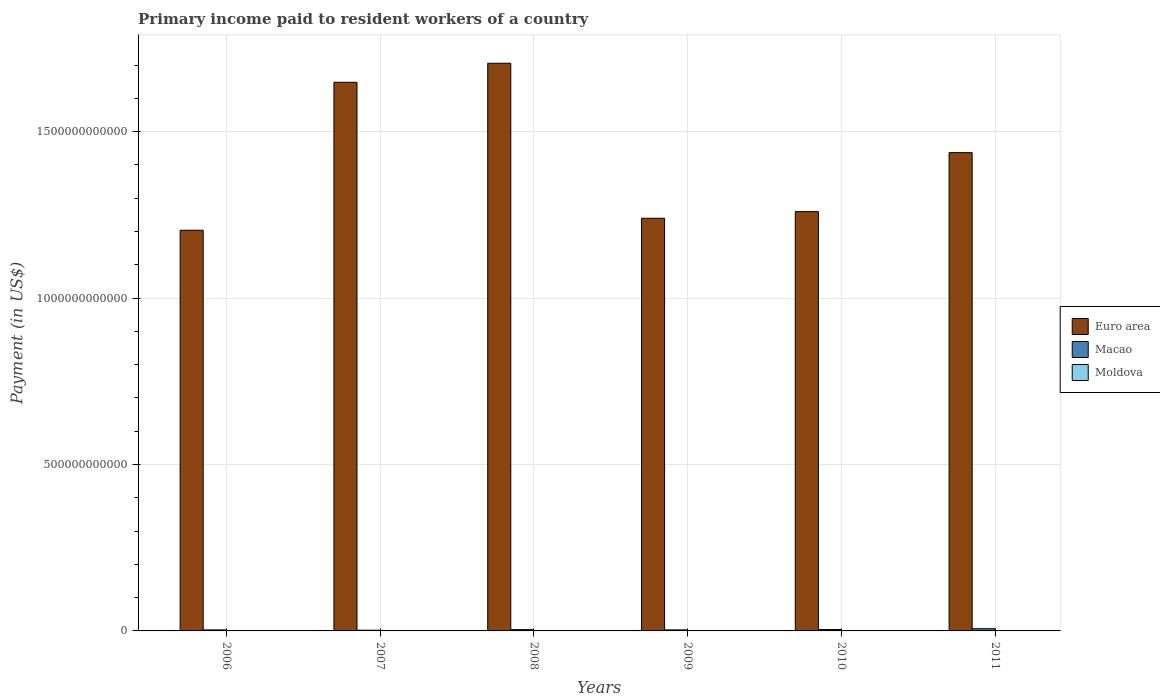How many different coloured bars are there?
Make the answer very short. 3. How many groups of bars are there?
Give a very brief answer. 6. What is the amount paid to workers in Macao in 2006?
Offer a terse response. 3.02e+09. Across all years, what is the maximum amount paid to workers in Euro area?
Give a very brief answer. 1.71e+12. Across all years, what is the minimum amount paid to workers in Macao?
Give a very brief answer. 2.18e+09. In which year was the amount paid to workers in Moldova maximum?
Provide a short and direct response. 2011. In which year was the amount paid to workers in Moldova minimum?
Ensure brevity in your answer.  2006. What is the total amount paid to workers in Macao in the graph?
Provide a short and direct response. 2.30e+1. What is the difference between the amount paid to workers in Euro area in 2007 and that in 2008?
Provide a succinct answer. -5.72e+1. What is the difference between the amount paid to workers in Euro area in 2009 and the amount paid to workers in Moldova in 2006?
Offer a terse response. 1.24e+12. What is the average amount paid to workers in Moldova per year?
Make the answer very short. 2.81e+08. In the year 2010, what is the difference between the amount paid to workers in Euro area and amount paid to workers in Macao?
Make the answer very short. 1.26e+12. What is the ratio of the amount paid to workers in Macao in 2006 to that in 2008?
Keep it short and to the point. 0.78. Is the amount paid to workers in Moldova in 2007 less than that in 2010?
Ensure brevity in your answer.  No. Is the difference between the amount paid to workers in Euro area in 2006 and 2010 greater than the difference between the amount paid to workers in Macao in 2006 and 2010?
Provide a short and direct response. No. What is the difference between the highest and the second highest amount paid to workers in Euro area?
Your answer should be very brief. 5.72e+1. What is the difference between the highest and the lowest amount paid to workers in Macao?
Offer a very short reply. 4.44e+09. Is the sum of the amount paid to workers in Macao in 2009 and 2010 greater than the maximum amount paid to workers in Euro area across all years?
Offer a very short reply. No. What does the 3rd bar from the left in 2007 represents?
Offer a very short reply. Moldova. What does the 3rd bar from the right in 2007 represents?
Ensure brevity in your answer.  Euro area. Is it the case that in every year, the sum of the amount paid to workers in Macao and amount paid to workers in Euro area is greater than the amount paid to workers in Moldova?
Offer a very short reply. Yes. How many bars are there?
Ensure brevity in your answer.  18. How many years are there in the graph?
Provide a short and direct response. 6. What is the difference between two consecutive major ticks on the Y-axis?
Give a very brief answer. 5.00e+11. Are the values on the major ticks of Y-axis written in scientific E-notation?
Your response must be concise. No. Where does the legend appear in the graph?
Your answer should be very brief. Center right. How many legend labels are there?
Make the answer very short. 3. How are the legend labels stacked?
Give a very brief answer. Vertical. What is the title of the graph?
Your answer should be very brief. Primary income paid to resident workers of a country. What is the label or title of the X-axis?
Offer a very short reply. Years. What is the label or title of the Y-axis?
Make the answer very short. Payment (in US$). What is the Payment (in US$) in Euro area in 2006?
Your response must be concise. 1.20e+12. What is the Payment (in US$) of Macao in 2006?
Provide a short and direct response. 3.02e+09. What is the Payment (in US$) in Moldova in 2006?
Your response must be concise. 2.03e+08. What is the Payment (in US$) of Euro area in 2007?
Your answer should be very brief. 1.65e+12. What is the Payment (in US$) of Macao in 2007?
Keep it short and to the point. 2.18e+09. What is the Payment (in US$) of Moldova in 2007?
Give a very brief answer. 2.94e+08. What is the Payment (in US$) in Euro area in 2008?
Provide a short and direct response. 1.71e+12. What is the Payment (in US$) of Macao in 2008?
Ensure brevity in your answer.  3.89e+09. What is the Payment (in US$) of Moldova in 2008?
Your answer should be compact. 3.01e+08. What is the Payment (in US$) of Euro area in 2009?
Your response must be concise. 1.24e+12. What is the Payment (in US$) of Macao in 2009?
Provide a short and direct response. 3.13e+09. What is the Payment (in US$) of Moldova in 2009?
Your response must be concise. 2.71e+08. What is the Payment (in US$) of Euro area in 2010?
Provide a short and direct response. 1.26e+12. What is the Payment (in US$) in Macao in 2010?
Ensure brevity in your answer.  4.12e+09. What is the Payment (in US$) in Moldova in 2010?
Your response must be concise. 2.62e+08. What is the Payment (in US$) of Euro area in 2011?
Provide a short and direct response. 1.44e+12. What is the Payment (in US$) of Macao in 2011?
Your answer should be compact. 6.62e+09. What is the Payment (in US$) of Moldova in 2011?
Give a very brief answer. 3.55e+08. Across all years, what is the maximum Payment (in US$) in Euro area?
Provide a succinct answer. 1.71e+12. Across all years, what is the maximum Payment (in US$) in Macao?
Offer a terse response. 6.62e+09. Across all years, what is the maximum Payment (in US$) in Moldova?
Give a very brief answer. 3.55e+08. Across all years, what is the minimum Payment (in US$) in Euro area?
Offer a very short reply. 1.20e+12. Across all years, what is the minimum Payment (in US$) in Macao?
Offer a very short reply. 2.18e+09. Across all years, what is the minimum Payment (in US$) in Moldova?
Keep it short and to the point. 2.03e+08. What is the total Payment (in US$) of Euro area in the graph?
Make the answer very short. 8.49e+12. What is the total Payment (in US$) of Macao in the graph?
Provide a succinct answer. 2.30e+1. What is the total Payment (in US$) in Moldova in the graph?
Keep it short and to the point. 1.69e+09. What is the difference between the Payment (in US$) of Euro area in 2006 and that in 2007?
Offer a terse response. -4.44e+11. What is the difference between the Payment (in US$) in Macao in 2006 and that in 2007?
Your response must be concise. 8.42e+08. What is the difference between the Payment (in US$) in Moldova in 2006 and that in 2007?
Your response must be concise. -9.03e+07. What is the difference between the Payment (in US$) of Euro area in 2006 and that in 2008?
Offer a terse response. -5.02e+11. What is the difference between the Payment (in US$) in Macao in 2006 and that in 2008?
Offer a terse response. -8.68e+08. What is the difference between the Payment (in US$) in Moldova in 2006 and that in 2008?
Offer a very short reply. -9.80e+07. What is the difference between the Payment (in US$) of Euro area in 2006 and that in 2009?
Offer a terse response. -3.60e+1. What is the difference between the Payment (in US$) in Macao in 2006 and that in 2009?
Offer a terse response. -1.04e+08. What is the difference between the Payment (in US$) in Moldova in 2006 and that in 2009?
Ensure brevity in your answer.  -6.74e+07. What is the difference between the Payment (in US$) of Euro area in 2006 and that in 2010?
Keep it short and to the point. -5.60e+1. What is the difference between the Payment (in US$) of Macao in 2006 and that in 2010?
Make the answer very short. -1.10e+09. What is the difference between the Payment (in US$) in Moldova in 2006 and that in 2010?
Provide a succinct answer. -5.89e+07. What is the difference between the Payment (in US$) in Euro area in 2006 and that in 2011?
Give a very brief answer. -2.33e+11. What is the difference between the Payment (in US$) in Macao in 2006 and that in 2011?
Offer a terse response. -3.60e+09. What is the difference between the Payment (in US$) of Moldova in 2006 and that in 2011?
Offer a very short reply. -1.52e+08. What is the difference between the Payment (in US$) in Euro area in 2007 and that in 2008?
Provide a succinct answer. -5.72e+1. What is the difference between the Payment (in US$) in Macao in 2007 and that in 2008?
Ensure brevity in your answer.  -1.71e+09. What is the difference between the Payment (in US$) in Moldova in 2007 and that in 2008?
Give a very brief answer. -7.77e+06. What is the difference between the Payment (in US$) in Euro area in 2007 and that in 2009?
Provide a succinct answer. 4.08e+11. What is the difference between the Payment (in US$) of Macao in 2007 and that in 2009?
Provide a succinct answer. -9.46e+08. What is the difference between the Payment (in US$) in Moldova in 2007 and that in 2009?
Offer a very short reply. 2.28e+07. What is the difference between the Payment (in US$) in Euro area in 2007 and that in 2010?
Make the answer very short. 3.88e+11. What is the difference between the Payment (in US$) in Macao in 2007 and that in 2010?
Offer a terse response. -1.94e+09. What is the difference between the Payment (in US$) of Moldova in 2007 and that in 2010?
Your response must be concise. 3.14e+07. What is the difference between the Payment (in US$) of Euro area in 2007 and that in 2011?
Your answer should be very brief. 2.11e+11. What is the difference between the Payment (in US$) in Macao in 2007 and that in 2011?
Provide a short and direct response. -4.44e+09. What is the difference between the Payment (in US$) of Moldova in 2007 and that in 2011?
Make the answer very short. -6.16e+07. What is the difference between the Payment (in US$) in Euro area in 2008 and that in 2009?
Give a very brief answer. 4.66e+11. What is the difference between the Payment (in US$) in Macao in 2008 and that in 2009?
Offer a terse response. 7.64e+08. What is the difference between the Payment (in US$) of Moldova in 2008 and that in 2009?
Offer a very short reply. 3.06e+07. What is the difference between the Payment (in US$) of Euro area in 2008 and that in 2010?
Your response must be concise. 4.46e+11. What is the difference between the Payment (in US$) of Macao in 2008 and that in 2010?
Provide a succinct answer. -2.30e+08. What is the difference between the Payment (in US$) in Moldova in 2008 and that in 2010?
Make the answer very short. 3.92e+07. What is the difference between the Payment (in US$) in Euro area in 2008 and that in 2011?
Your answer should be compact. 2.69e+11. What is the difference between the Payment (in US$) of Macao in 2008 and that in 2011?
Keep it short and to the point. -2.73e+09. What is the difference between the Payment (in US$) in Moldova in 2008 and that in 2011?
Keep it short and to the point. -5.38e+07. What is the difference between the Payment (in US$) of Euro area in 2009 and that in 2010?
Your response must be concise. -2.00e+1. What is the difference between the Payment (in US$) in Macao in 2009 and that in 2010?
Ensure brevity in your answer.  -9.95e+08. What is the difference between the Payment (in US$) of Moldova in 2009 and that in 2010?
Offer a terse response. 8.54e+06. What is the difference between the Payment (in US$) of Euro area in 2009 and that in 2011?
Offer a very short reply. -1.97e+11. What is the difference between the Payment (in US$) in Macao in 2009 and that in 2011?
Offer a terse response. -3.49e+09. What is the difference between the Payment (in US$) in Moldova in 2009 and that in 2011?
Your answer should be very brief. -8.44e+07. What is the difference between the Payment (in US$) of Euro area in 2010 and that in 2011?
Your response must be concise. -1.77e+11. What is the difference between the Payment (in US$) in Macao in 2010 and that in 2011?
Offer a terse response. -2.50e+09. What is the difference between the Payment (in US$) in Moldova in 2010 and that in 2011?
Ensure brevity in your answer.  -9.30e+07. What is the difference between the Payment (in US$) in Euro area in 2006 and the Payment (in US$) in Macao in 2007?
Keep it short and to the point. 1.20e+12. What is the difference between the Payment (in US$) in Euro area in 2006 and the Payment (in US$) in Moldova in 2007?
Keep it short and to the point. 1.20e+12. What is the difference between the Payment (in US$) of Macao in 2006 and the Payment (in US$) of Moldova in 2007?
Give a very brief answer. 2.73e+09. What is the difference between the Payment (in US$) in Euro area in 2006 and the Payment (in US$) in Macao in 2008?
Your answer should be compact. 1.20e+12. What is the difference between the Payment (in US$) of Euro area in 2006 and the Payment (in US$) of Moldova in 2008?
Provide a succinct answer. 1.20e+12. What is the difference between the Payment (in US$) of Macao in 2006 and the Payment (in US$) of Moldova in 2008?
Ensure brevity in your answer.  2.72e+09. What is the difference between the Payment (in US$) in Euro area in 2006 and the Payment (in US$) in Macao in 2009?
Provide a succinct answer. 1.20e+12. What is the difference between the Payment (in US$) in Euro area in 2006 and the Payment (in US$) in Moldova in 2009?
Give a very brief answer. 1.20e+12. What is the difference between the Payment (in US$) of Macao in 2006 and the Payment (in US$) of Moldova in 2009?
Make the answer very short. 2.75e+09. What is the difference between the Payment (in US$) of Euro area in 2006 and the Payment (in US$) of Macao in 2010?
Provide a succinct answer. 1.20e+12. What is the difference between the Payment (in US$) in Euro area in 2006 and the Payment (in US$) in Moldova in 2010?
Ensure brevity in your answer.  1.20e+12. What is the difference between the Payment (in US$) of Macao in 2006 and the Payment (in US$) of Moldova in 2010?
Provide a short and direct response. 2.76e+09. What is the difference between the Payment (in US$) in Euro area in 2006 and the Payment (in US$) in Macao in 2011?
Give a very brief answer. 1.20e+12. What is the difference between the Payment (in US$) in Euro area in 2006 and the Payment (in US$) in Moldova in 2011?
Offer a terse response. 1.20e+12. What is the difference between the Payment (in US$) of Macao in 2006 and the Payment (in US$) of Moldova in 2011?
Provide a short and direct response. 2.67e+09. What is the difference between the Payment (in US$) in Euro area in 2007 and the Payment (in US$) in Macao in 2008?
Provide a short and direct response. 1.64e+12. What is the difference between the Payment (in US$) of Euro area in 2007 and the Payment (in US$) of Moldova in 2008?
Keep it short and to the point. 1.65e+12. What is the difference between the Payment (in US$) of Macao in 2007 and the Payment (in US$) of Moldova in 2008?
Ensure brevity in your answer.  1.88e+09. What is the difference between the Payment (in US$) of Euro area in 2007 and the Payment (in US$) of Macao in 2009?
Ensure brevity in your answer.  1.65e+12. What is the difference between the Payment (in US$) of Euro area in 2007 and the Payment (in US$) of Moldova in 2009?
Your answer should be compact. 1.65e+12. What is the difference between the Payment (in US$) in Macao in 2007 and the Payment (in US$) in Moldova in 2009?
Provide a succinct answer. 1.91e+09. What is the difference between the Payment (in US$) in Euro area in 2007 and the Payment (in US$) in Macao in 2010?
Your answer should be very brief. 1.64e+12. What is the difference between the Payment (in US$) of Euro area in 2007 and the Payment (in US$) of Moldova in 2010?
Your response must be concise. 1.65e+12. What is the difference between the Payment (in US$) of Macao in 2007 and the Payment (in US$) of Moldova in 2010?
Ensure brevity in your answer.  1.92e+09. What is the difference between the Payment (in US$) in Euro area in 2007 and the Payment (in US$) in Macao in 2011?
Make the answer very short. 1.64e+12. What is the difference between the Payment (in US$) of Euro area in 2007 and the Payment (in US$) of Moldova in 2011?
Your response must be concise. 1.65e+12. What is the difference between the Payment (in US$) in Macao in 2007 and the Payment (in US$) in Moldova in 2011?
Provide a short and direct response. 1.83e+09. What is the difference between the Payment (in US$) of Euro area in 2008 and the Payment (in US$) of Macao in 2009?
Provide a succinct answer. 1.70e+12. What is the difference between the Payment (in US$) in Euro area in 2008 and the Payment (in US$) in Moldova in 2009?
Your answer should be compact. 1.71e+12. What is the difference between the Payment (in US$) of Macao in 2008 and the Payment (in US$) of Moldova in 2009?
Keep it short and to the point. 3.62e+09. What is the difference between the Payment (in US$) in Euro area in 2008 and the Payment (in US$) in Macao in 2010?
Your answer should be compact. 1.70e+12. What is the difference between the Payment (in US$) of Euro area in 2008 and the Payment (in US$) of Moldova in 2010?
Give a very brief answer. 1.71e+12. What is the difference between the Payment (in US$) in Macao in 2008 and the Payment (in US$) in Moldova in 2010?
Give a very brief answer. 3.63e+09. What is the difference between the Payment (in US$) of Euro area in 2008 and the Payment (in US$) of Macao in 2011?
Ensure brevity in your answer.  1.70e+12. What is the difference between the Payment (in US$) of Euro area in 2008 and the Payment (in US$) of Moldova in 2011?
Offer a very short reply. 1.71e+12. What is the difference between the Payment (in US$) in Macao in 2008 and the Payment (in US$) in Moldova in 2011?
Your answer should be compact. 3.54e+09. What is the difference between the Payment (in US$) in Euro area in 2009 and the Payment (in US$) in Macao in 2010?
Ensure brevity in your answer.  1.24e+12. What is the difference between the Payment (in US$) in Euro area in 2009 and the Payment (in US$) in Moldova in 2010?
Give a very brief answer. 1.24e+12. What is the difference between the Payment (in US$) of Macao in 2009 and the Payment (in US$) of Moldova in 2010?
Your answer should be compact. 2.87e+09. What is the difference between the Payment (in US$) in Euro area in 2009 and the Payment (in US$) in Macao in 2011?
Your response must be concise. 1.23e+12. What is the difference between the Payment (in US$) of Euro area in 2009 and the Payment (in US$) of Moldova in 2011?
Your response must be concise. 1.24e+12. What is the difference between the Payment (in US$) of Macao in 2009 and the Payment (in US$) of Moldova in 2011?
Provide a short and direct response. 2.77e+09. What is the difference between the Payment (in US$) in Euro area in 2010 and the Payment (in US$) in Macao in 2011?
Give a very brief answer. 1.25e+12. What is the difference between the Payment (in US$) in Euro area in 2010 and the Payment (in US$) in Moldova in 2011?
Your answer should be very brief. 1.26e+12. What is the difference between the Payment (in US$) of Macao in 2010 and the Payment (in US$) of Moldova in 2011?
Ensure brevity in your answer.  3.77e+09. What is the average Payment (in US$) in Euro area per year?
Your answer should be compact. 1.42e+12. What is the average Payment (in US$) of Macao per year?
Give a very brief answer. 3.83e+09. What is the average Payment (in US$) in Moldova per year?
Keep it short and to the point. 2.81e+08. In the year 2006, what is the difference between the Payment (in US$) of Euro area and Payment (in US$) of Macao?
Ensure brevity in your answer.  1.20e+12. In the year 2006, what is the difference between the Payment (in US$) in Euro area and Payment (in US$) in Moldova?
Give a very brief answer. 1.20e+12. In the year 2006, what is the difference between the Payment (in US$) of Macao and Payment (in US$) of Moldova?
Provide a succinct answer. 2.82e+09. In the year 2007, what is the difference between the Payment (in US$) in Euro area and Payment (in US$) in Macao?
Provide a succinct answer. 1.65e+12. In the year 2007, what is the difference between the Payment (in US$) of Euro area and Payment (in US$) of Moldova?
Offer a terse response. 1.65e+12. In the year 2007, what is the difference between the Payment (in US$) of Macao and Payment (in US$) of Moldova?
Provide a short and direct response. 1.89e+09. In the year 2008, what is the difference between the Payment (in US$) in Euro area and Payment (in US$) in Macao?
Keep it short and to the point. 1.70e+12. In the year 2008, what is the difference between the Payment (in US$) of Euro area and Payment (in US$) of Moldova?
Make the answer very short. 1.71e+12. In the year 2008, what is the difference between the Payment (in US$) of Macao and Payment (in US$) of Moldova?
Make the answer very short. 3.59e+09. In the year 2009, what is the difference between the Payment (in US$) in Euro area and Payment (in US$) in Macao?
Offer a very short reply. 1.24e+12. In the year 2009, what is the difference between the Payment (in US$) in Euro area and Payment (in US$) in Moldova?
Your answer should be compact. 1.24e+12. In the year 2009, what is the difference between the Payment (in US$) of Macao and Payment (in US$) of Moldova?
Keep it short and to the point. 2.86e+09. In the year 2010, what is the difference between the Payment (in US$) in Euro area and Payment (in US$) in Macao?
Provide a succinct answer. 1.26e+12. In the year 2010, what is the difference between the Payment (in US$) in Euro area and Payment (in US$) in Moldova?
Ensure brevity in your answer.  1.26e+12. In the year 2010, what is the difference between the Payment (in US$) of Macao and Payment (in US$) of Moldova?
Keep it short and to the point. 3.86e+09. In the year 2011, what is the difference between the Payment (in US$) of Euro area and Payment (in US$) of Macao?
Make the answer very short. 1.43e+12. In the year 2011, what is the difference between the Payment (in US$) of Euro area and Payment (in US$) of Moldova?
Your answer should be compact. 1.44e+12. In the year 2011, what is the difference between the Payment (in US$) in Macao and Payment (in US$) in Moldova?
Ensure brevity in your answer.  6.27e+09. What is the ratio of the Payment (in US$) in Euro area in 2006 to that in 2007?
Your response must be concise. 0.73. What is the ratio of the Payment (in US$) of Macao in 2006 to that in 2007?
Provide a succinct answer. 1.39. What is the ratio of the Payment (in US$) in Moldova in 2006 to that in 2007?
Offer a very short reply. 0.69. What is the ratio of the Payment (in US$) of Euro area in 2006 to that in 2008?
Your response must be concise. 0.71. What is the ratio of the Payment (in US$) in Macao in 2006 to that in 2008?
Give a very brief answer. 0.78. What is the ratio of the Payment (in US$) of Moldova in 2006 to that in 2008?
Give a very brief answer. 0.67. What is the ratio of the Payment (in US$) in Macao in 2006 to that in 2009?
Provide a short and direct response. 0.97. What is the ratio of the Payment (in US$) of Moldova in 2006 to that in 2009?
Keep it short and to the point. 0.75. What is the ratio of the Payment (in US$) in Euro area in 2006 to that in 2010?
Your answer should be compact. 0.96. What is the ratio of the Payment (in US$) in Macao in 2006 to that in 2010?
Provide a short and direct response. 0.73. What is the ratio of the Payment (in US$) in Moldova in 2006 to that in 2010?
Your answer should be very brief. 0.78. What is the ratio of the Payment (in US$) in Euro area in 2006 to that in 2011?
Offer a very short reply. 0.84. What is the ratio of the Payment (in US$) in Macao in 2006 to that in 2011?
Ensure brevity in your answer.  0.46. What is the ratio of the Payment (in US$) in Moldova in 2006 to that in 2011?
Your answer should be compact. 0.57. What is the ratio of the Payment (in US$) of Euro area in 2007 to that in 2008?
Offer a very short reply. 0.97. What is the ratio of the Payment (in US$) in Macao in 2007 to that in 2008?
Your answer should be compact. 0.56. What is the ratio of the Payment (in US$) in Moldova in 2007 to that in 2008?
Your answer should be very brief. 0.97. What is the ratio of the Payment (in US$) in Euro area in 2007 to that in 2009?
Provide a succinct answer. 1.33. What is the ratio of the Payment (in US$) in Macao in 2007 to that in 2009?
Give a very brief answer. 0.7. What is the ratio of the Payment (in US$) in Moldova in 2007 to that in 2009?
Keep it short and to the point. 1.08. What is the ratio of the Payment (in US$) of Euro area in 2007 to that in 2010?
Ensure brevity in your answer.  1.31. What is the ratio of the Payment (in US$) of Macao in 2007 to that in 2010?
Make the answer very short. 0.53. What is the ratio of the Payment (in US$) in Moldova in 2007 to that in 2010?
Your answer should be very brief. 1.12. What is the ratio of the Payment (in US$) of Euro area in 2007 to that in 2011?
Provide a short and direct response. 1.15. What is the ratio of the Payment (in US$) in Macao in 2007 to that in 2011?
Give a very brief answer. 0.33. What is the ratio of the Payment (in US$) in Moldova in 2007 to that in 2011?
Offer a terse response. 0.83. What is the ratio of the Payment (in US$) of Euro area in 2008 to that in 2009?
Provide a succinct answer. 1.38. What is the ratio of the Payment (in US$) in Macao in 2008 to that in 2009?
Provide a succinct answer. 1.24. What is the ratio of the Payment (in US$) in Moldova in 2008 to that in 2009?
Your answer should be compact. 1.11. What is the ratio of the Payment (in US$) in Euro area in 2008 to that in 2010?
Provide a succinct answer. 1.35. What is the ratio of the Payment (in US$) in Macao in 2008 to that in 2010?
Keep it short and to the point. 0.94. What is the ratio of the Payment (in US$) of Moldova in 2008 to that in 2010?
Your answer should be compact. 1.15. What is the ratio of the Payment (in US$) in Euro area in 2008 to that in 2011?
Give a very brief answer. 1.19. What is the ratio of the Payment (in US$) of Macao in 2008 to that in 2011?
Provide a short and direct response. 0.59. What is the ratio of the Payment (in US$) in Moldova in 2008 to that in 2011?
Your answer should be compact. 0.85. What is the ratio of the Payment (in US$) in Euro area in 2009 to that in 2010?
Offer a very short reply. 0.98. What is the ratio of the Payment (in US$) in Macao in 2009 to that in 2010?
Provide a short and direct response. 0.76. What is the ratio of the Payment (in US$) of Moldova in 2009 to that in 2010?
Ensure brevity in your answer.  1.03. What is the ratio of the Payment (in US$) of Euro area in 2009 to that in 2011?
Keep it short and to the point. 0.86. What is the ratio of the Payment (in US$) in Macao in 2009 to that in 2011?
Offer a very short reply. 0.47. What is the ratio of the Payment (in US$) in Moldova in 2009 to that in 2011?
Provide a succinct answer. 0.76. What is the ratio of the Payment (in US$) in Euro area in 2010 to that in 2011?
Your response must be concise. 0.88. What is the ratio of the Payment (in US$) of Macao in 2010 to that in 2011?
Your response must be concise. 0.62. What is the ratio of the Payment (in US$) of Moldova in 2010 to that in 2011?
Give a very brief answer. 0.74. What is the difference between the highest and the second highest Payment (in US$) in Euro area?
Offer a terse response. 5.72e+1. What is the difference between the highest and the second highest Payment (in US$) in Macao?
Give a very brief answer. 2.50e+09. What is the difference between the highest and the second highest Payment (in US$) in Moldova?
Ensure brevity in your answer.  5.38e+07. What is the difference between the highest and the lowest Payment (in US$) of Euro area?
Your answer should be compact. 5.02e+11. What is the difference between the highest and the lowest Payment (in US$) in Macao?
Offer a very short reply. 4.44e+09. What is the difference between the highest and the lowest Payment (in US$) in Moldova?
Ensure brevity in your answer.  1.52e+08. 